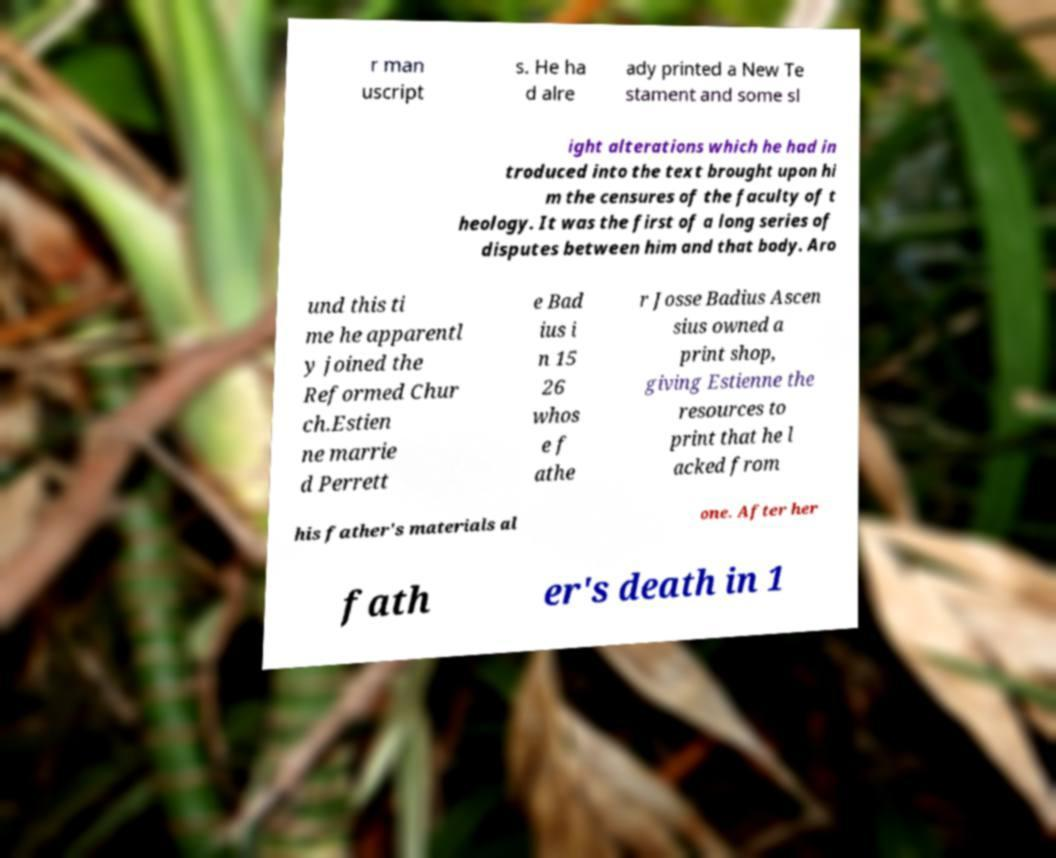Could you assist in decoding the text presented in this image and type it out clearly? r man uscript s. He ha d alre ady printed a New Te stament and some sl ight alterations which he had in troduced into the text brought upon hi m the censures of the faculty of t heology. It was the first of a long series of disputes between him and that body. Aro und this ti me he apparentl y joined the Reformed Chur ch.Estien ne marrie d Perrett e Bad ius i n 15 26 whos e f athe r Josse Badius Ascen sius owned a print shop, giving Estienne the resources to print that he l acked from his father's materials al one. After her fath er's death in 1 